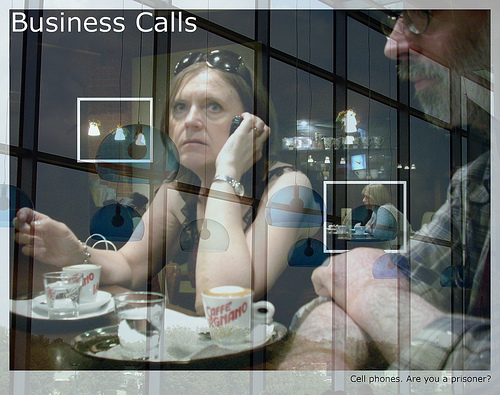Is the man to the right of a plate? Yes, the man is to the right of a plate. 